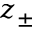<formula> <loc_0><loc_0><loc_500><loc_500>z _ { \pm }</formula> 